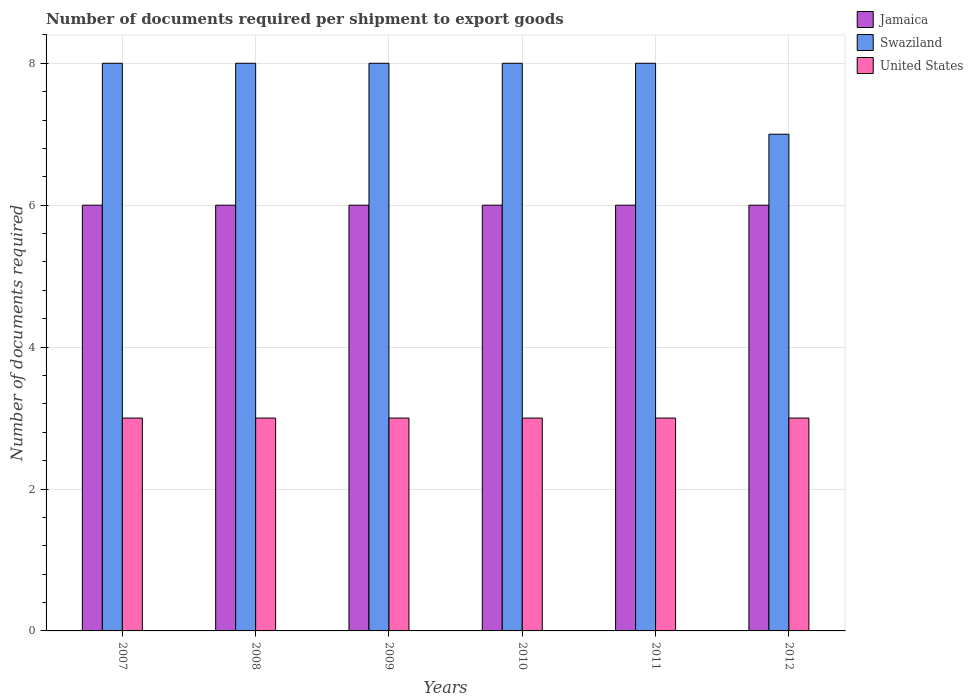How many different coloured bars are there?
Your answer should be compact. 3. Are the number of bars on each tick of the X-axis equal?
Give a very brief answer. Yes. In how many cases, is the number of bars for a given year not equal to the number of legend labels?
Provide a succinct answer. 0. What is the number of documents required per shipment to export goods in United States in 2009?
Offer a very short reply. 3. Across all years, what is the minimum number of documents required per shipment to export goods in United States?
Offer a terse response. 3. In which year was the number of documents required per shipment to export goods in United States minimum?
Provide a succinct answer. 2007. What is the total number of documents required per shipment to export goods in United States in the graph?
Your response must be concise. 18. What is the difference between the number of documents required per shipment to export goods in Swaziland in 2007 and that in 2009?
Your answer should be very brief. 0. What is the difference between the number of documents required per shipment to export goods in United States in 2011 and the number of documents required per shipment to export goods in Swaziland in 2012?
Provide a succinct answer. -4. What is the average number of documents required per shipment to export goods in Swaziland per year?
Offer a terse response. 7.83. In the year 2008, what is the difference between the number of documents required per shipment to export goods in Swaziland and number of documents required per shipment to export goods in Jamaica?
Offer a terse response. 2. What is the ratio of the number of documents required per shipment to export goods in United States in 2010 to that in 2011?
Make the answer very short. 1. Is the number of documents required per shipment to export goods in Swaziland in 2010 less than that in 2012?
Your response must be concise. No. Is the difference between the number of documents required per shipment to export goods in Swaziland in 2007 and 2011 greater than the difference between the number of documents required per shipment to export goods in Jamaica in 2007 and 2011?
Ensure brevity in your answer.  No. What is the difference between the highest and the lowest number of documents required per shipment to export goods in Jamaica?
Provide a succinct answer. 0. In how many years, is the number of documents required per shipment to export goods in United States greater than the average number of documents required per shipment to export goods in United States taken over all years?
Offer a terse response. 0. What does the 2nd bar from the left in 2007 represents?
Offer a terse response. Swaziland. What does the 3rd bar from the right in 2008 represents?
Provide a short and direct response. Jamaica. Is it the case that in every year, the sum of the number of documents required per shipment to export goods in United States and number of documents required per shipment to export goods in Jamaica is greater than the number of documents required per shipment to export goods in Swaziland?
Provide a succinct answer. Yes. How many bars are there?
Give a very brief answer. 18. What is the difference between two consecutive major ticks on the Y-axis?
Give a very brief answer. 2. Are the values on the major ticks of Y-axis written in scientific E-notation?
Provide a short and direct response. No. Where does the legend appear in the graph?
Your response must be concise. Top right. How are the legend labels stacked?
Keep it short and to the point. Vertical. What is the title of the graph?
Provide a succinct answer. Number of documents required per shipment to export goods. Does "Low income" appear as one of the legend labels in the graph?
Your answer should be very brief. No. What is the label or title of the X-axis?
Your response must be concise. Years. What is the label or title of the Y-axis?
Give a very brief answer. Number of documents required. What is the Number of documents required of Jamaica in 2007?
Your answer should be very brief. 6. What is the Number of documents required in United States in 2007?
Your answer should be compact. 3. What is the Number of documents required in Jamaica in 2008?
Your answer should be very brief. 6. What is the Number of documents required in Swaziland in 2008?
Provide a succinct answer. 8. What is the Number of documents required of United States in 2008?
Your answer should be very brief. 3. What is the Number of documents required of Jamaica in 2009?
Offer a terse response. 6. What is the Number of documents required in Swaziland in 2009?
Offer a very short reply. 8. What is the Number of documents required of United States in 2009?
Ensure brevity in your answer.  3. What is the Number of documents required of Jamaica in 2010?
Make the answer very short. 6. What is the Number of documents required in Jamaica in 2011?
Your response must be concise. 6. What is the Number of documents required of United States in 2011?
Offer a very short reply. 3. What is the Number of documents required of Swaziland in 2012?
Provide a succinct answer. 7. What is the Number of documents required in United States in 2012?
Your answer should be very brief. 3. Across all years, what is the maximum Number of documents required of Swaziland?
Your answer should be compact. 8. Across all years, what is the minimum Number of documents required in Swaziland?
Keep it short and to the point. 7. What is the total Number of documents required of Swaziland in the graph?
Offer a very short reply. 47. What is the difference between the Number of documents required of Swaziland in 2007 and that in 2008?
Provide a succinct answer. 0. What is the difference between the Number of documents required in United States in 2007 and that in 2008?
Your response must be concise. 0. What is the difference between the Number of documents required in Jamaica in 2007 and that in 2009?
Your answer should be very brief. 0. What is the difference between the Number of documents required of Jamaica in 2007 and that in 2010?
Provide a succinct answer. 0. What is the difference between the Number of documents required of Swaziland in 2007 and that in 2010?
Your response must be concise. 0. What is the difference between the Number of documents required of United States in 2007 and that in 2010?
Your answer should be very brief. 0. What is the difference between the Number of documents required in Jamaica in 2007 and that in 2011?
Offer a terse response. 0. What is the difference between the Number of documents required in United States in 2007 and that in 2011?
Keep it short and to the point. 0. What is the difference between the Number of documents required of Jamaica in 2007 and that in 2012?
Provide a succinct answer. 0. What is the difference between the Number of documents required of United States in 2007 and that in 2012?
Your answer should be very brief. 0. What is the difference between the Number of documents required in Jamaica in 2008 and that in 2009?
Your response must be concise. 0. What is the difference between the Number of documents required of United States in 2008 and that in 2009?
Ensure brevity in your answer.  0. What is the difference between the Number of documents required of Swaziland in 2008 and that in 2010?
Your answer should be very brief. 0. What is the difference between the Number of documents required in Swaziland in 2008 and that in 2011?
Offer a terse response. 0. What is the difference between the Number of documents required in United States in 2008 and that in 2011?
Give a very brief answer. 0. What is the difference between the Number of documents required of Swaziland in 2008 and that in 2012?
Ensure brevity in your answer.  1. What is the difference between the Number of documents required of Swaziland in 2009 and that in 2010?
Keep it short and to the point. 0. What is the difference between the Number of documents required of Jamaica in 2009 and that in 2012?
Provide a short and direct response. 0. What is the difference between the Number of documents required of United States in 2009 and that in 2012?
Ensure brevity in your answer.  0. What is the difference between the Number of documents required in Jamaica in 2010 and that in 2011?
Give a very brief answer. 0. What is the difference between the Number of documents required of Swaziland in 2010 and that in 2011?
Offer a terse response. 0. What is the difference between the Number of documents required in United States in 2010 and that in 2012?
Offer a very short reply. 0. What is the difference between the Number of documents required in Swaziland in 2011 and that in 2012?
Your response must be concise. 1. What is the difference between the Number of documents required in Jamaica in 2007 and the Number of documents required in Swaziland in 2008?
Offer a terse response. -2. What is the difference between the Number of documents required in Swaziland in 2007 and the Number of documents required in United States in 2008?
Your response must be concise. 5. What is the difference between the Number of documents required in Jamaica in 2007 and the Number of documents required in United States in 2009?
Give a very brief answer. 3. What is the difference between the Number of documents required in Jamaica in 2007 and the Number of documents required in United States in 2010?
Your response must be concise. 3. What is the difference between the Number of documents required of Jamaica in 2007 and the Number of documents required of United States in 2011?
Ensure brevity in your answer.  3. What is the difference between the Number of documents required of Jamaica in 2007 and the Number of documents required of Swaziland in 2012?
Your response must be concise. -1. What is the difference between the Number of documents required in Jamaica in 2008 and the Number of documents required in Swaziland in 2009?
Offer a very short reply. -2. What is the difference between the Number of documents required in Jamaica in 2008 and the Number of documents required in United States in 2009?
Make the answer very short. 3. What is the difference between the Number of documents required of Swaziland in 2008 and the Number of documents required of United States in 2009?
Keep it short and to the point. 5. What is the difference between the Number of documents required of Jamaica in 2008 and the Number of documents required of Swaziland in 2010?
Your answer should be very brief. -2. What is the difference between the Number of documents required of Jamaica in 2008 and the Number of documents required of Swaziland in 2011?
Ensure brevity in your answer.  -2. What is the difference between the Number of documents required of Swaziland in 2008 and the Number of documents required of United States in 2011?
Offer a terse response. 5. What is the difference between the Number of documents required in Jamaica in 2008 and the Number of documents required in United States in 2012?
Offer a very short reply. 3. What is the difference between the Number of documents required in Swaziland in 2008 and the Number of documents required in United States in 2012?
Offer a terse response. 5. What is the difference between the Number of documents required of Jamaica in 2009 and the Number of documents required of Swaziland in 2010?
Ensure brevity in your answer.  -2. What is the difference between the Number of documents required in Swaziland in 2009 and the Number of documents required in United States in 2010?
Offer a terse response. 5. What is the difference between the Number of documents required of Swaziland in 2009 and the Number of documents required of United States in 2012?
Make the answer very short. 5. What is the difference between the Number of documents required in Jamaica in 2010 and the Number of documents required in United States in 2011?
Ensure brevity in your answer.  3. What is the difference between the Number of documents required in Jamaica in 2010 and the Number of documents required in Swaziland in 2012?
Your answer should be very brief. -1. What is the difference between the Number of documents required in Jamaica in 2010 and the Number of documents required in United States in 2012?
Make the answer very short. 3. What is the difference between the Number of documents required in Swaziland in 2010 and the Number of documents required in United States in 2012?
Make the answer very short. 5. What is the difference between the Number of documents required of Jamaica in 2011 and the Number of documents required of Swaziland in 2012?
Your response must be concise. -1. What is the difference between the Number of documents required in Swaziland in 2011 and the Number of documents required in United States in 2012?
Keep it short and to the point. 5. What is the average Number of documents required in Swaziland per year?
Offer a very short reply. 7.83. In the year 2007, what is the difference between the Number of documents required in Jamaica and Number of documents required in United States?
Provide a succinct answer. 3. In the year 2008, what is the difference between the Number of documents required in Jamaica and Number of documents required in Swaziland?
Your answer should be very brief. -2. In the year 2009, what is the difference between the Number of documents required of Jamaica and Number of documents required of United States?
Your answer should be very brief. 3. In the year 2012, what is the difference between the Number of documents required of Jamaica and Number of documents required of United States?
Your response must be concise. 3. What is the ratio of the Number of documents required in Jamaica in 2007 to that in 2008?
Offer a terse response. 1. What is the ratio of the Number of documents required of Swaziland in 2007 to that in 2008?
Provide a short and direct response. 1. What is the ratio of the Number of documents required of Jamaica in 2007 to that in 2009?
Offer a terse response. 1. What is the ratio of the Number of documents required of United States in 2007 to that in 2009?
Keep it short and to the point. 1. What is the ratio of the Number of documents required of Jamaica in 2007 to that in 2010?
Your response must be concise. 1. What is the ratio of the Number of documents required in United States in 2007 to that in 2010?
Offer a terse response. 1. What is the ratio of the Number of documents required of Jamaica in 2007 to that in 2011?
Give a very brief answer. 1. What is the ratio of the Number of documents required in Swaziland in 2007 to that in 2011?
Keep it short and to the point. 1. What is the ratio of the Number of documents required in United States in 2007 to that in 2011?
Provide a short and direct response. 1. What is the ratio of the Number of documents required of Jamaica in 2008 to that in 2009?
Provide a succinct answer. 1. What is the ratio of the Number of documents required of Jamaica in 2008 to that in 2010?
Ensure brevity in your answer.  1. What is the ratio of the Number of documents required of Swaziland in 2008 to that in 2010?
Your answer should be very brief. 1. What is the ratio of the Number of documents required of Jamaica in 2008 to that in 2011?
Offer a terse response. 1. What is the ratio of the Number of documents required of Swaziland in 2008 to that in 2011?
Offer a very short reply. 1. What is the ratio of the Number of documents required of Jamaica in 2008 to that in 2012?
Make the answer very short. 1. What is the ratio of the Number of documents required in Jamaica in 2009 to that in 2010?
Make the answer very short. 1. What is the ratio of the Number of documents required of Swaziland in 2009 to that in 2010?
Offer a very short reply. 1. What is the ratio of the Number of documents required in Jamaica in 2009 to that in 2011?
Offer a very short reply. 1. What is the ratio of the Number of documents required in Jamaica in 2009 to that in 2012?
Make the answer very short. 1. What is the ratio of the Number of documents required in United States in 2009 to that in 2012?
Provide a succinct answer. 1. What is the ratio of the Number of documents required of Jamaica in 2010 to that in 2011?
Make the answer very short. 1. What is the ratio of the Number of documents required in United States in 2010 to that in 2011?
Your answer should be compact. 1. What is the ratio of the Number of documents required of Jamaica in 2010 to that in 2012?
Your response must be concise. 1. What is the ratio of the Number of documents required in United States in 2010 to that in 2012?
Give a very brief answer. 1. What is the difference between the highest and the second highest Number of documents required in Swaziland?
Your answer should be very brief. 0. 